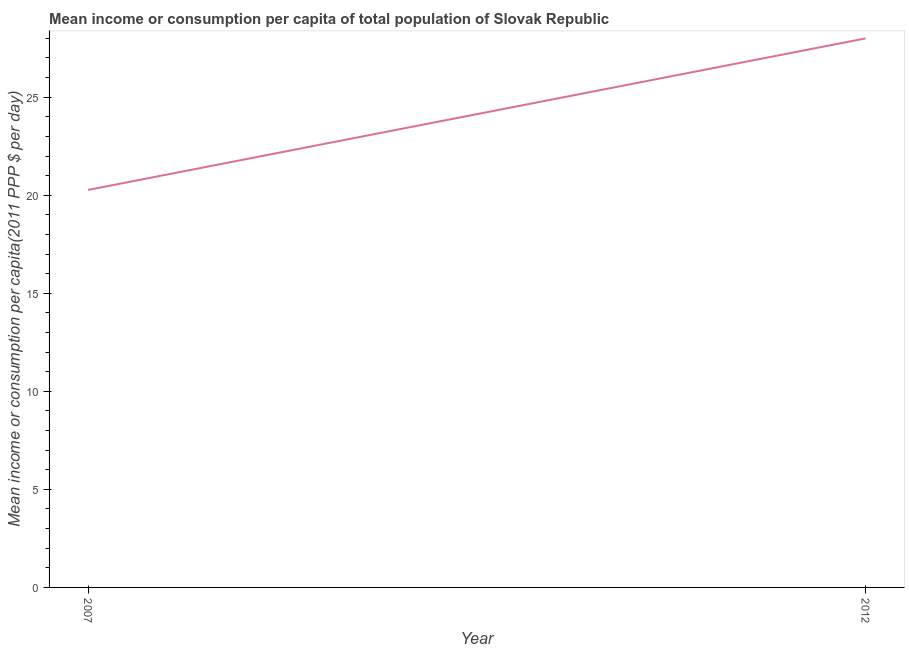What is the mean income or consumption in 2012?
Offer a terse response. 28. Across all years, what is the maximum mean income or consumption?
Your answer should be compact. 28. Across all years, what is the minimum mean income or consumption?
Your answer should be compact. 20.27. In which year was the mean income or consumption minimum?
Provide a short and direct response. 2007. What is the sum of the mean income or consumption?
Ensure brevity in your answer.  48.27. What is the difference between the mean income or consumption in 2007 and 2012?
Your answer should be compact. -7.73. What is the average mean income or consumption per year?
Provide a short and direct response. 24.13. What is the median mean income or consumption?
Your answer should be compact. 24.13. What is the ratio of the mean income or consumption in 2007 to that in 2012?
Make the answer very short. 0.72. Is the mean income or consumption in 2007 less than that in 2012?
Make the answer very short. Yes. Does the mean income or consumption monotonically increase over the years?
Give a very brief answer. Yes. How many lines are there?
Make the answer very short. 1. What is the difference between two consecutive major ticks on the Y-axis?
Ensure brevity in your answer.  5. What is the title of the graph?
Your answer should be compact. Mean income or consumption per capita of total population of Slovak Republic. What is the label or title of the Y-axis?
Offer a very short reply. Mean income or consumption per capita(2011 PPP $ per day). What is the Mean income or consumption per capita(2011 PPP $ per day) in 2007?
Provide a short and direct response. 20.27. What is the Mean income or consumption per capita(2011 PPP $ per day) of 2012?
Your answer should be compact. 28. What is the difference between the Mean income or consumption per capita(2011 PPP $ per day) in 2007 and 2012?
Your answer should be compact. -7.73. What is the ratio of the Mean income or consumption per capita(2011 PPP $ per day) in 2007 to that in 2012?
Ensure brevity in your answer.  0.72. 